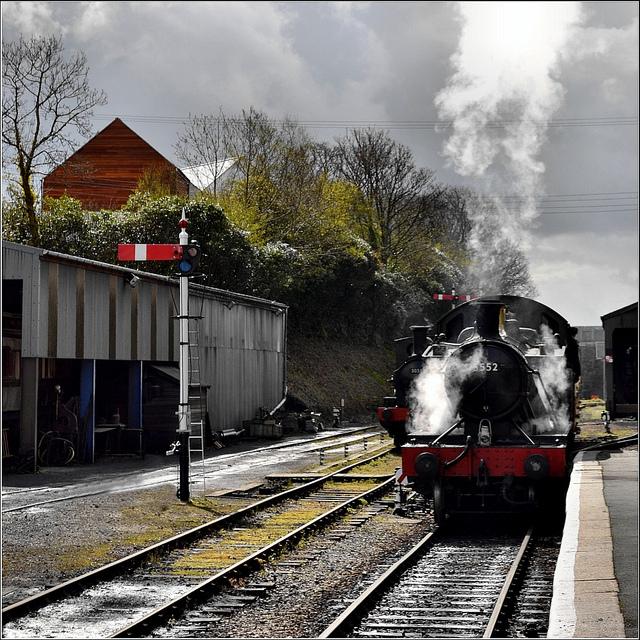When was the first steam engine put into use?
Keep it brief. 1800. What color is the front of the train?
Short answer required. Black. What does this train use for power?
Give a very brief answer. Steam. 